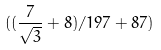<formula> <loc_0><loc_0><loc_500><loc_500>( ( \frac { 7 } { \sqrt { 3 } } + 8 ) / 1 9 7 + 8 7 )</formula> 